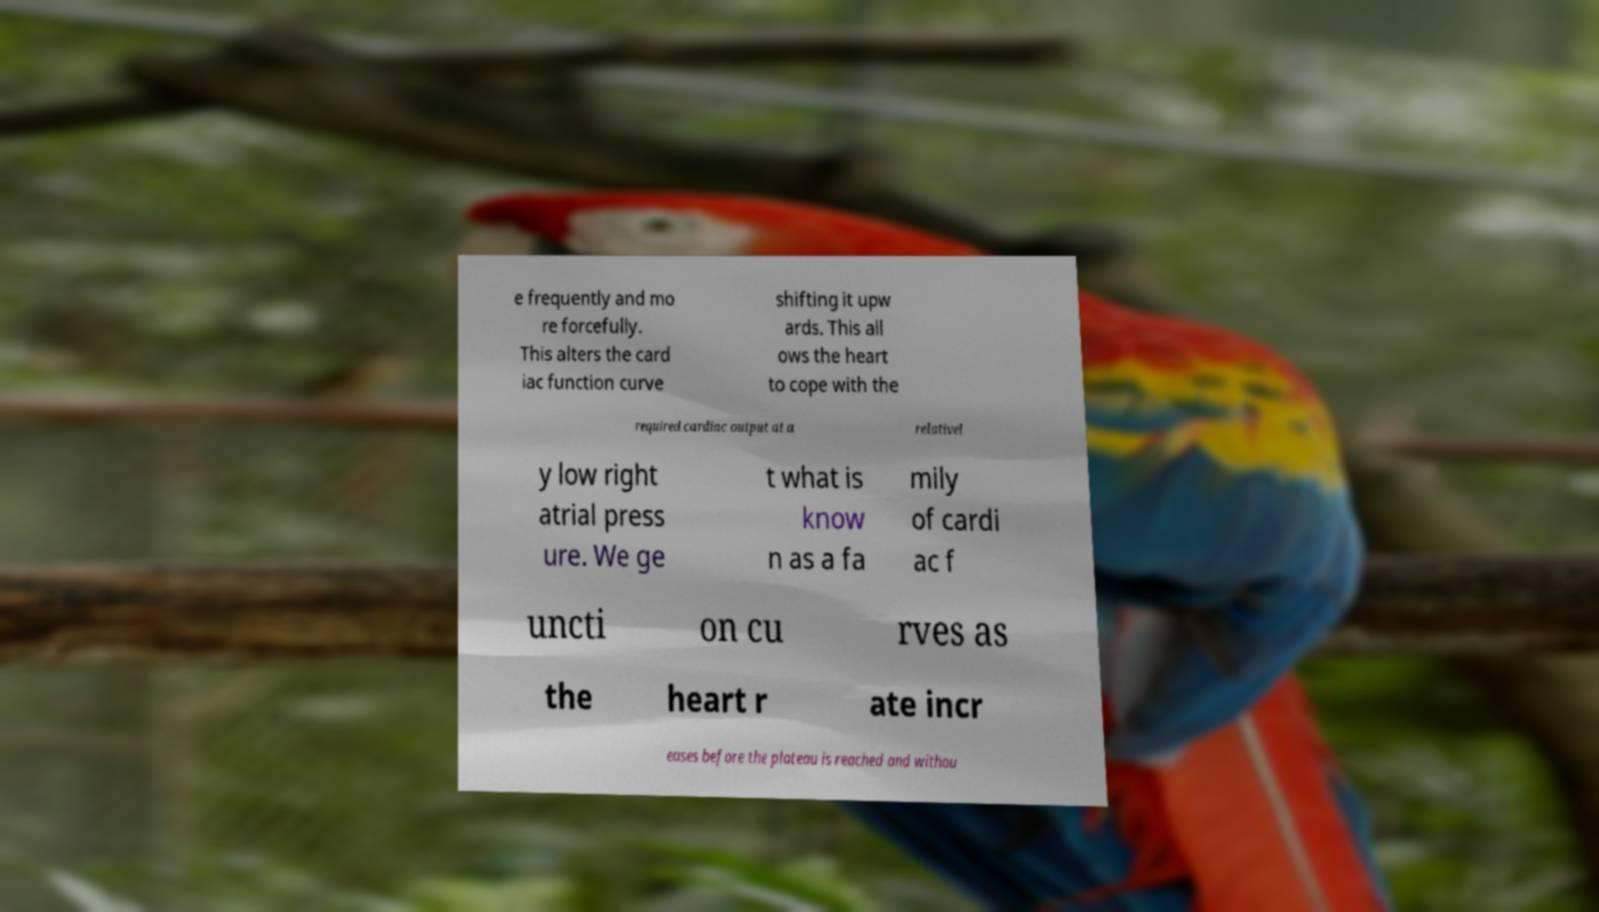Please read and relay the text visible in this image. What does it say? e frequently and mo re forcefully. This alters the card iac function curve shifting it upw ards. This all ows the heart to cope with the required cardiac output at a relativel y low right atrial press ure. We ge t what is know n as a fa mily of cardi ac f uncti on cu rves as the heart r ate incr eases before the plateau is reached and withou 